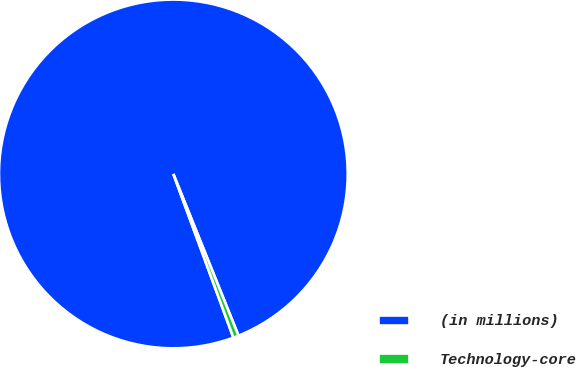Convert chart. <chart><loc_0><loc_0><loc_500><loc_500><pie_chart><fcel>(in millions)<fcel>Technology-core<nl><fcel>99.5%<fcel>0.5%<nl></chart> 